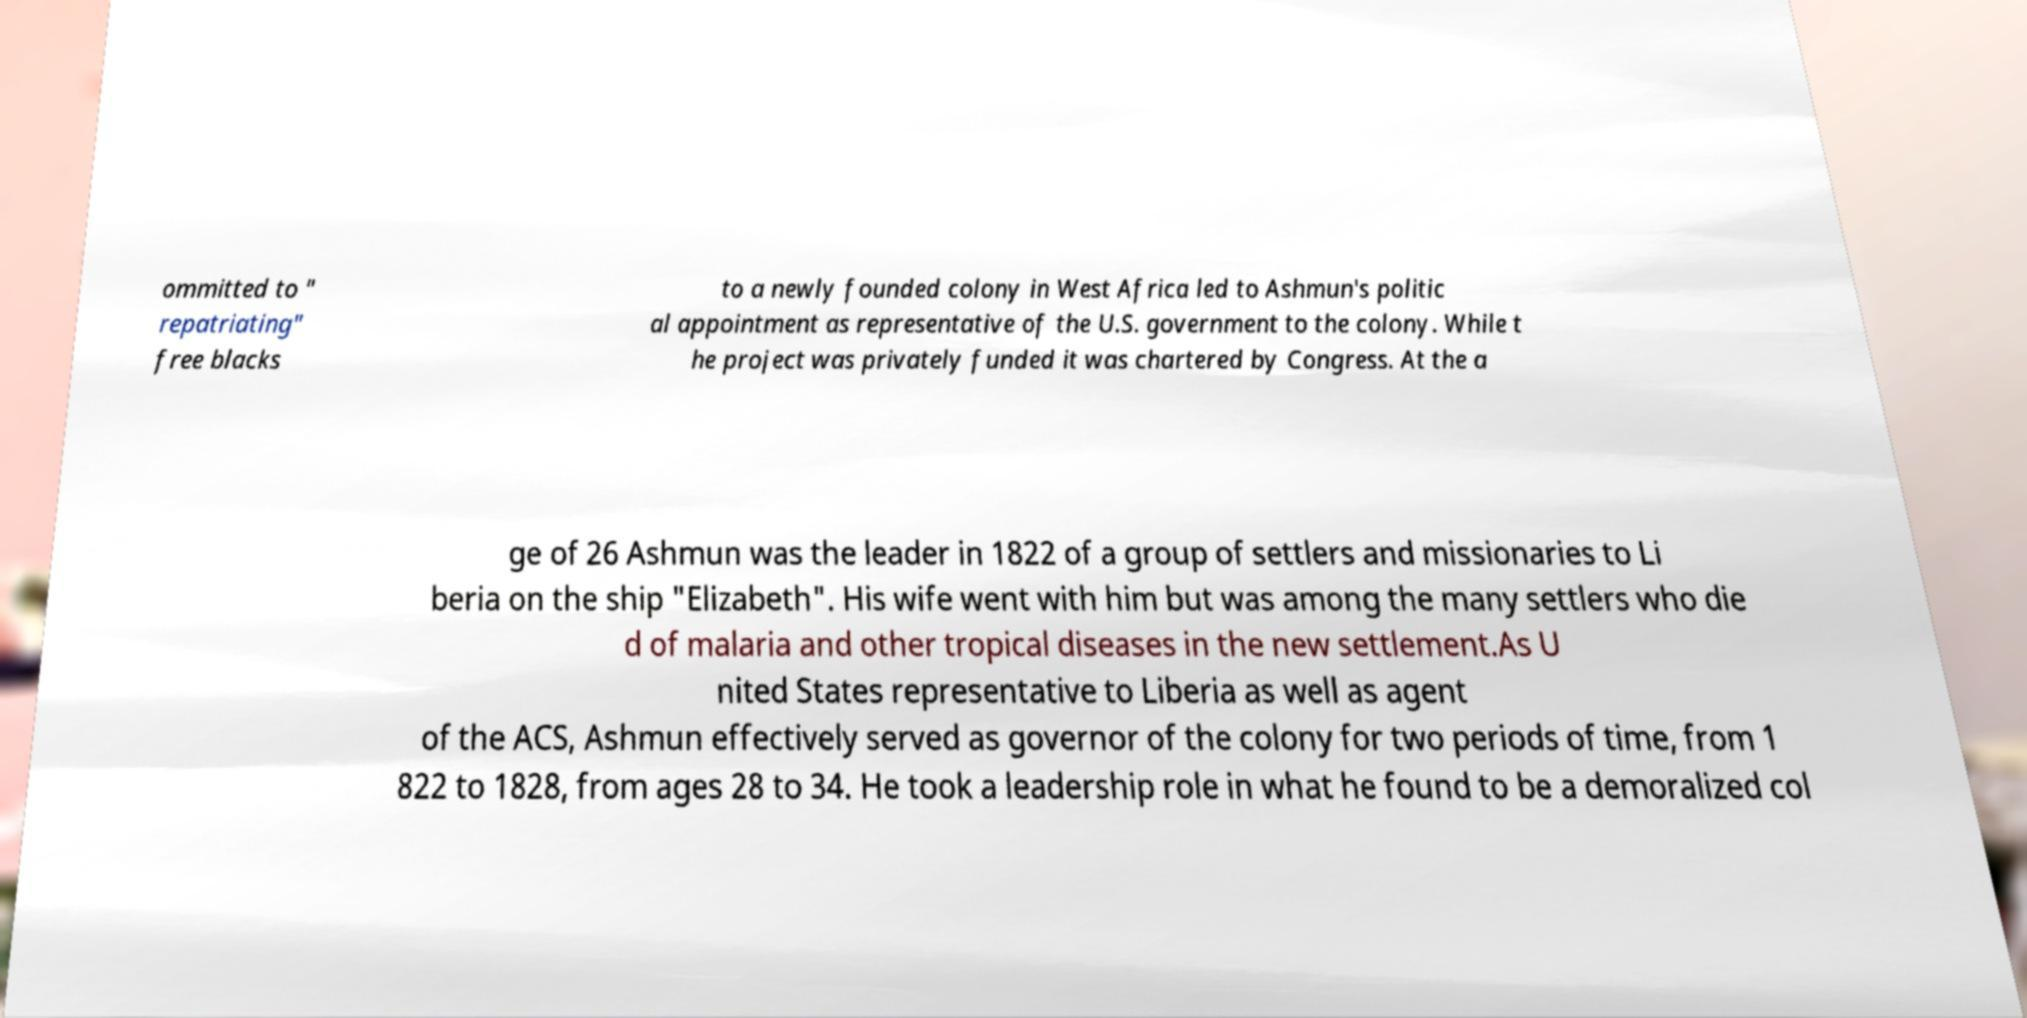Please identify and transcribe the text found in this image. ommitted to " repatriating" free blacks to a newly founded colony in West Africa led to Ashmun's politic al appointment as representative of the U.S. government to the colony. While t he project was privately funded it was chartered by Congress. At the a ge of 26 Ashmun was the leader in 1822 of a group of settlers and missionaries to Li beria on the ship "Elizabeth". His wife went with him but was among the many settlers who die d of malaria and other tropical diseases in the new settlement.As U nited States representative to Liberia as well as agent of the ACS, Ashmun effectively served as governor of the colony for two periods of time, from 1 822 to 1828, from ages 28 to 34. He took a leadership role in what he found to be a demoralized col 